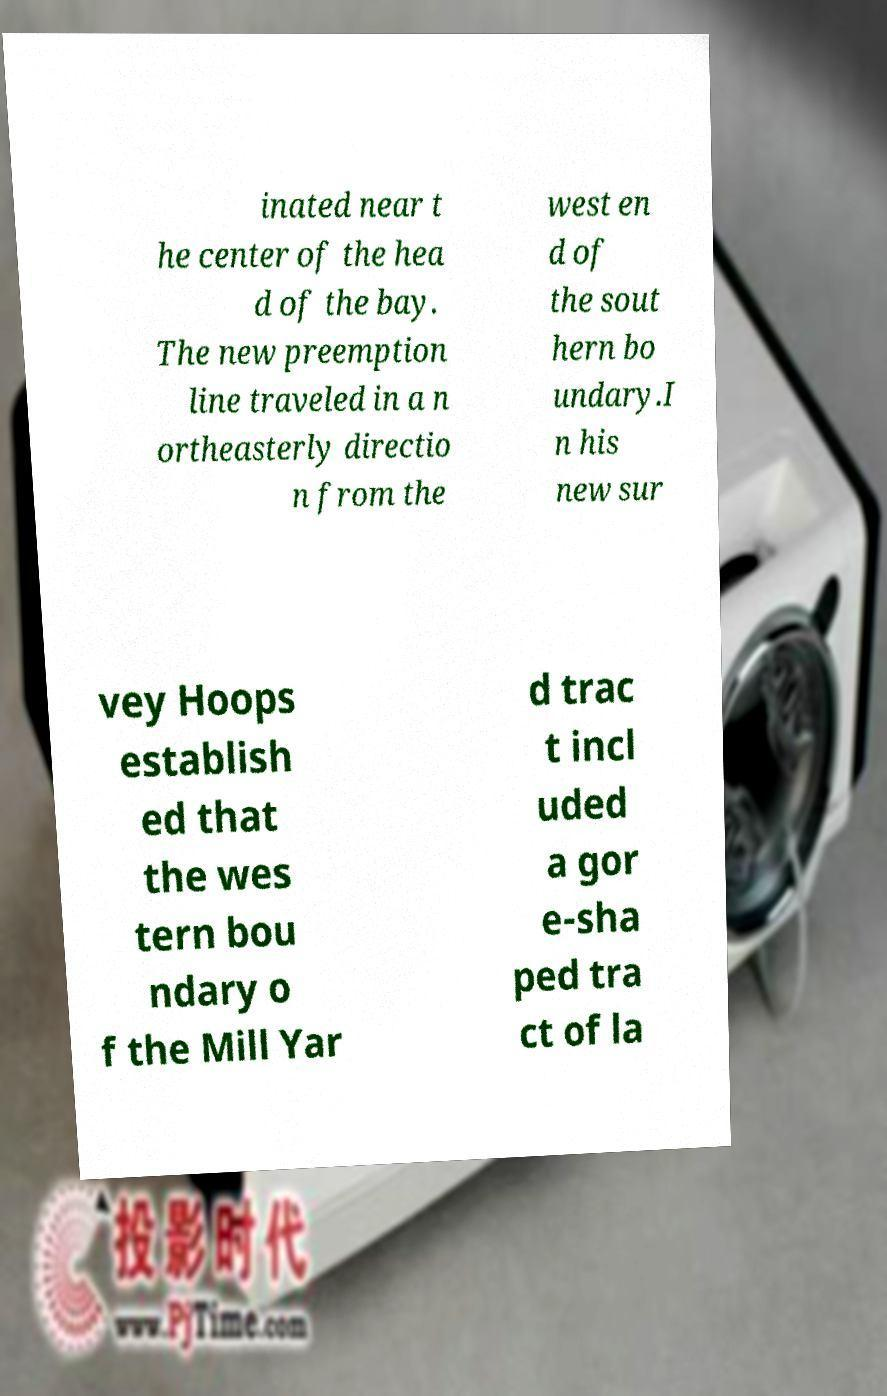Can you accurately transcribe the text from the provided image for me? inated near t he center of the hea d of the bay. The new preemption line traveled in a n ortheasterly directio n from the west en d of the sout hern bo undary.I n his new sur vey Hoops establish ed that the wes tern bou ndary o f the Mill Yar d trac t incl uded a gor e-sha ped tra ct of la 